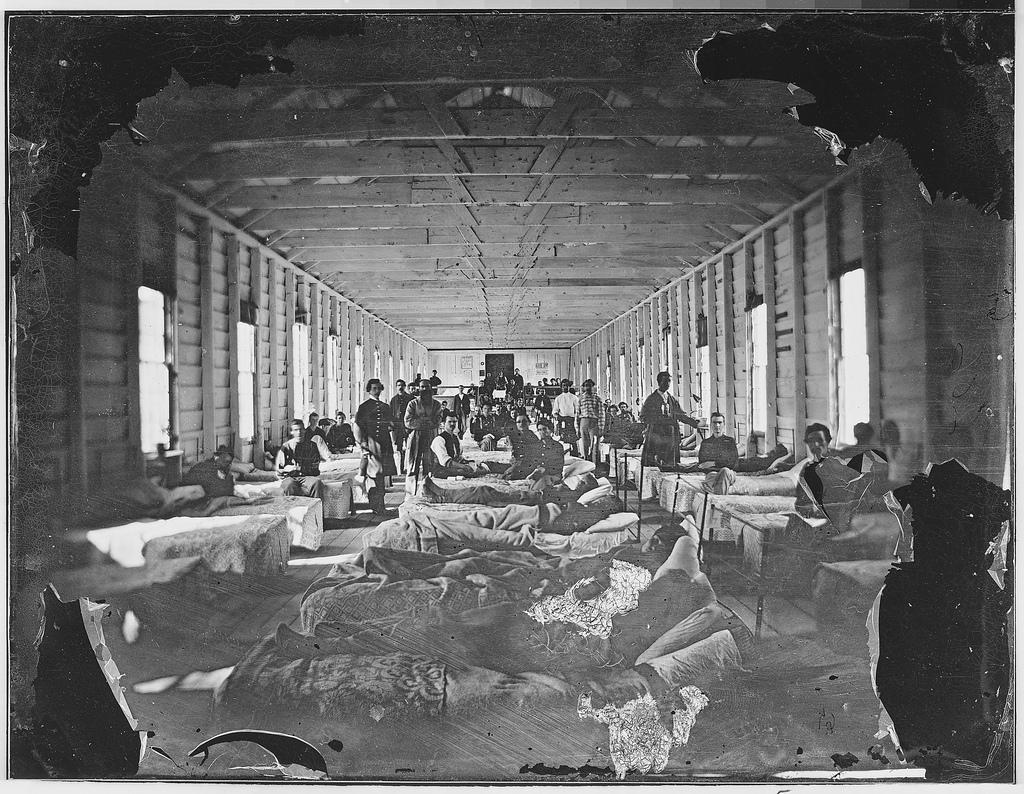Can you describe this image briefly? This is a photo. In this picture we can see a group of people and some of them are lying on the beds and some of them are standing and also we can see the windows, roof, wall, floor, beds, blankets, pillows. 